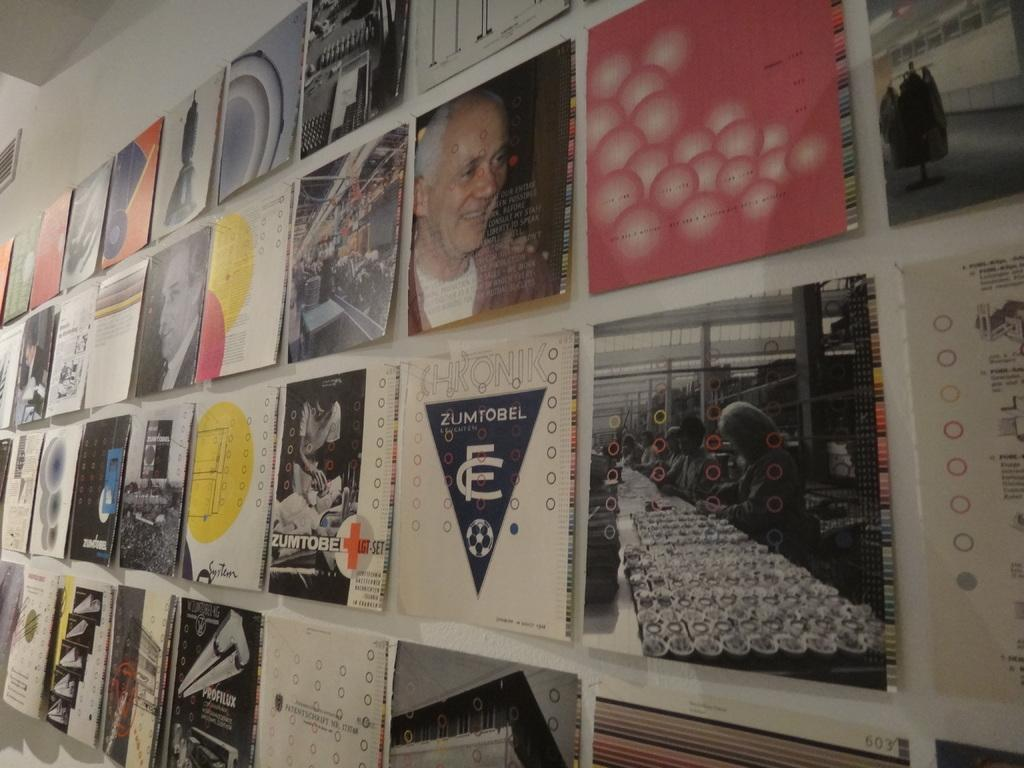<image>
Provide a brief description of the given image. Different poster designs, two of which are Zumtobel, are hung on a wall. 